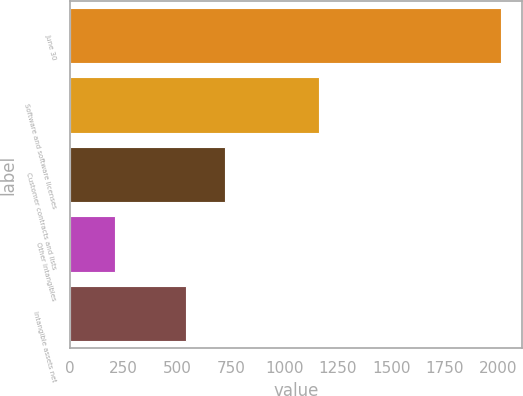Convert chart. <chart><loc_0><loc_0><loc_500><loc_500><bar_chart><fcel>June 30<fcel>Software and software licenses<fcel>Customer contracts and lists<fcel>Other intangibles<fcel>Intangible assets net<nl><fcel>2010<fcel>1160<fcel>722.45<fcel>209.5<fcel>542.4<nl></chart> 